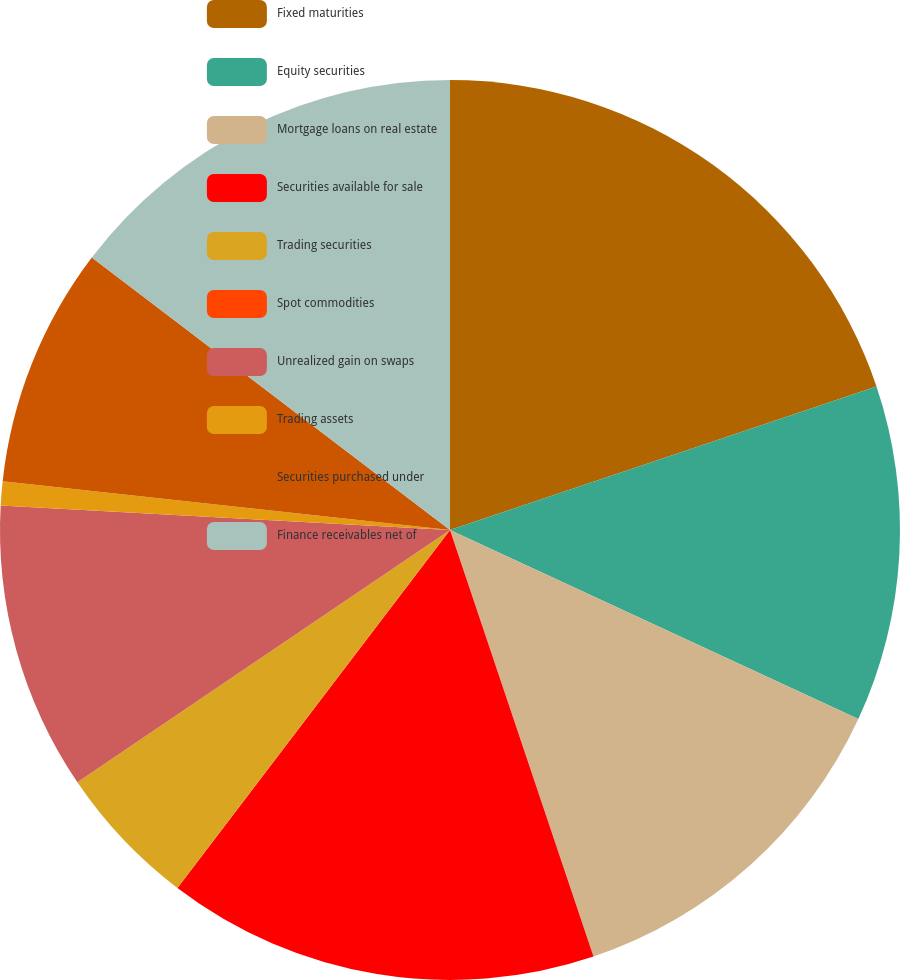Convert chart. <chart><loc_0><loc_0><loc_500><loc_500><pie_chart><fcel>Fixed maturities<fcel>Equity securities<fcel>Mortgage loans on real estate<fcel>Securities available for sale<fcel>Trading securities<fcel>Spot commodities<fcel>Unrealized gain on swaps<fcel>Trading assets<fcel>Securities purchased under<fcel>Finance receivables net of<nl><fcel>19.83%<fcel>12.07%<fcel>12.93%<fcel>15.52%<fcel>5.17%<fcel>0.0%<fcel>10.34%<fcel>0.86%<fcel>8.62%<fcel>14.65%<nl></chart> 